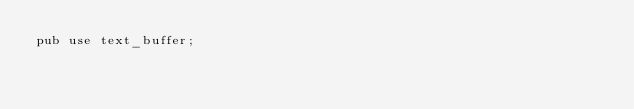Convert code to text. <code><loc_0><loc_0><loc_500><loc_500><_Rust_>pub use text_buffer;
</code> 